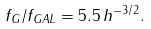<formula> <loc_0><loc_0><loc_500><loc_500>f _ { G } / f _ { G A L } = 5 . 5 \, h ^ { - 3 / 2 } .</formula> 